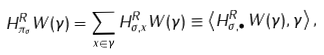<formula> <loc_0><loc_0><loc_500><loc_500>H _ { \pi _ { \sigma } } ^ { R } W ( \gamma ) = \sum _ { x \in \gamma } H _ { \sigma , x } ^ { R } W ( \gamma ) \equiv \left \langle H _ { \sigma , \bullet } ^ { R } \, W ( \gamma ) , \gamma \right \rangle ,</formula> 